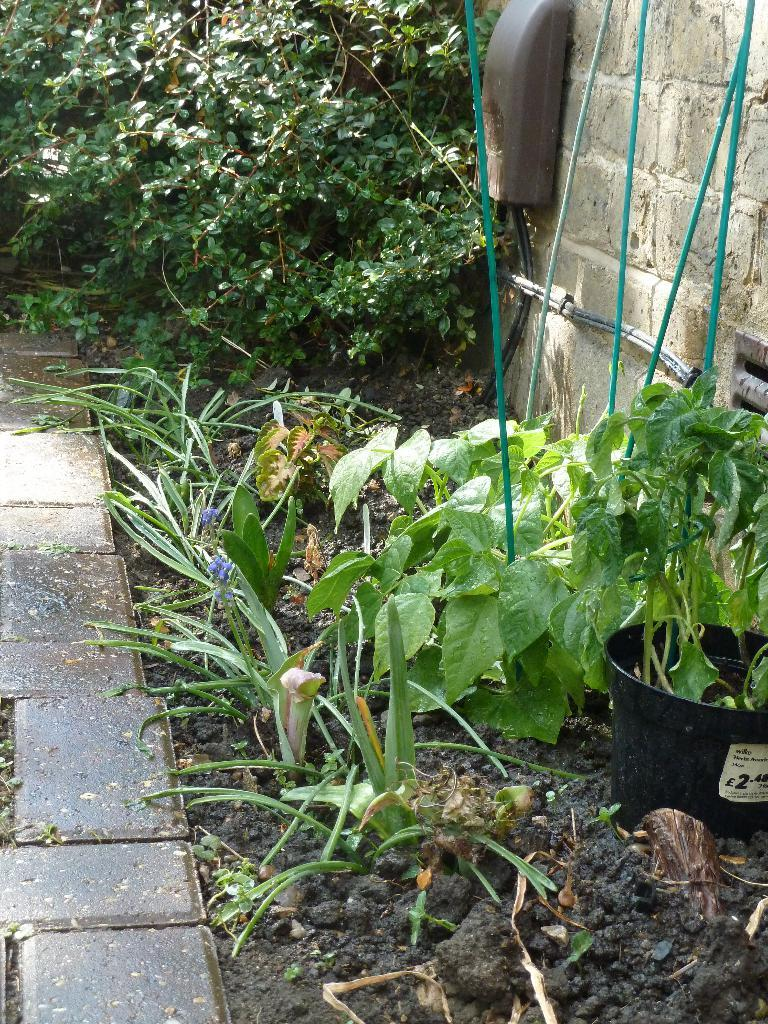What type of vegetation can be seen in the backyard? There are plants and trees in the backyard. What type of tooth can be seen in the image? There is no tooth present in the image; it features plants and trees in a backyard. Is there a creature visible in the image? There is no creature visible in the image; it only features plants and trees in a backyard. 